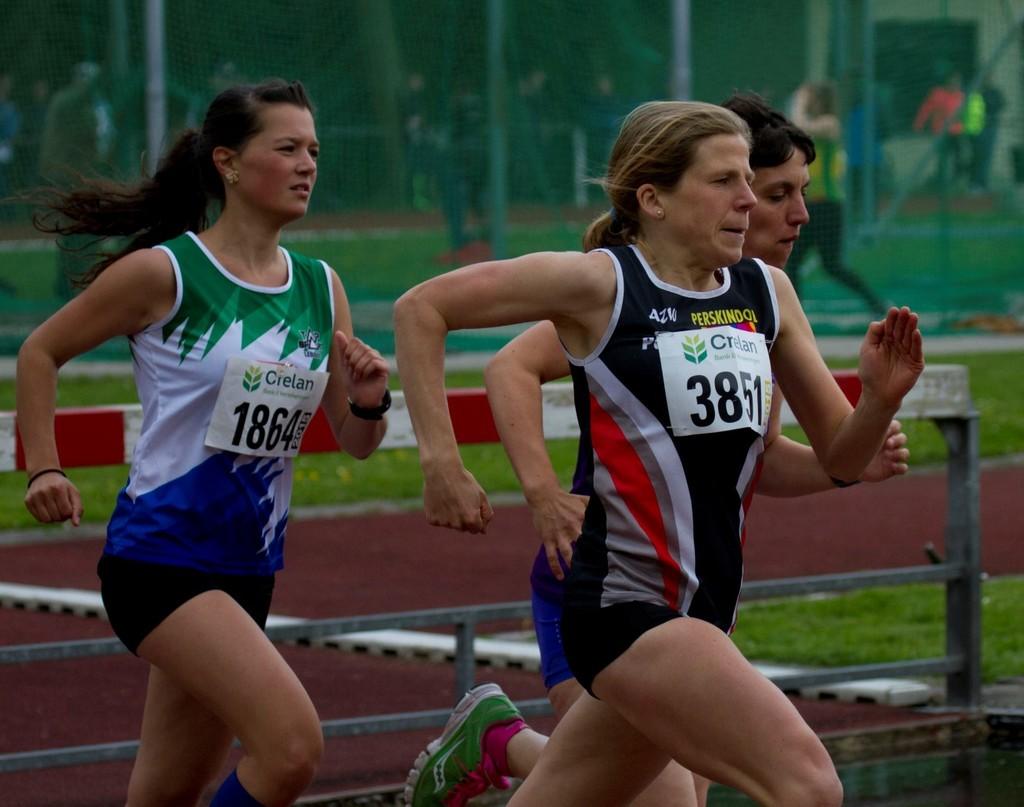What is the player number in black?
Your answer should be very brief. 3851. 